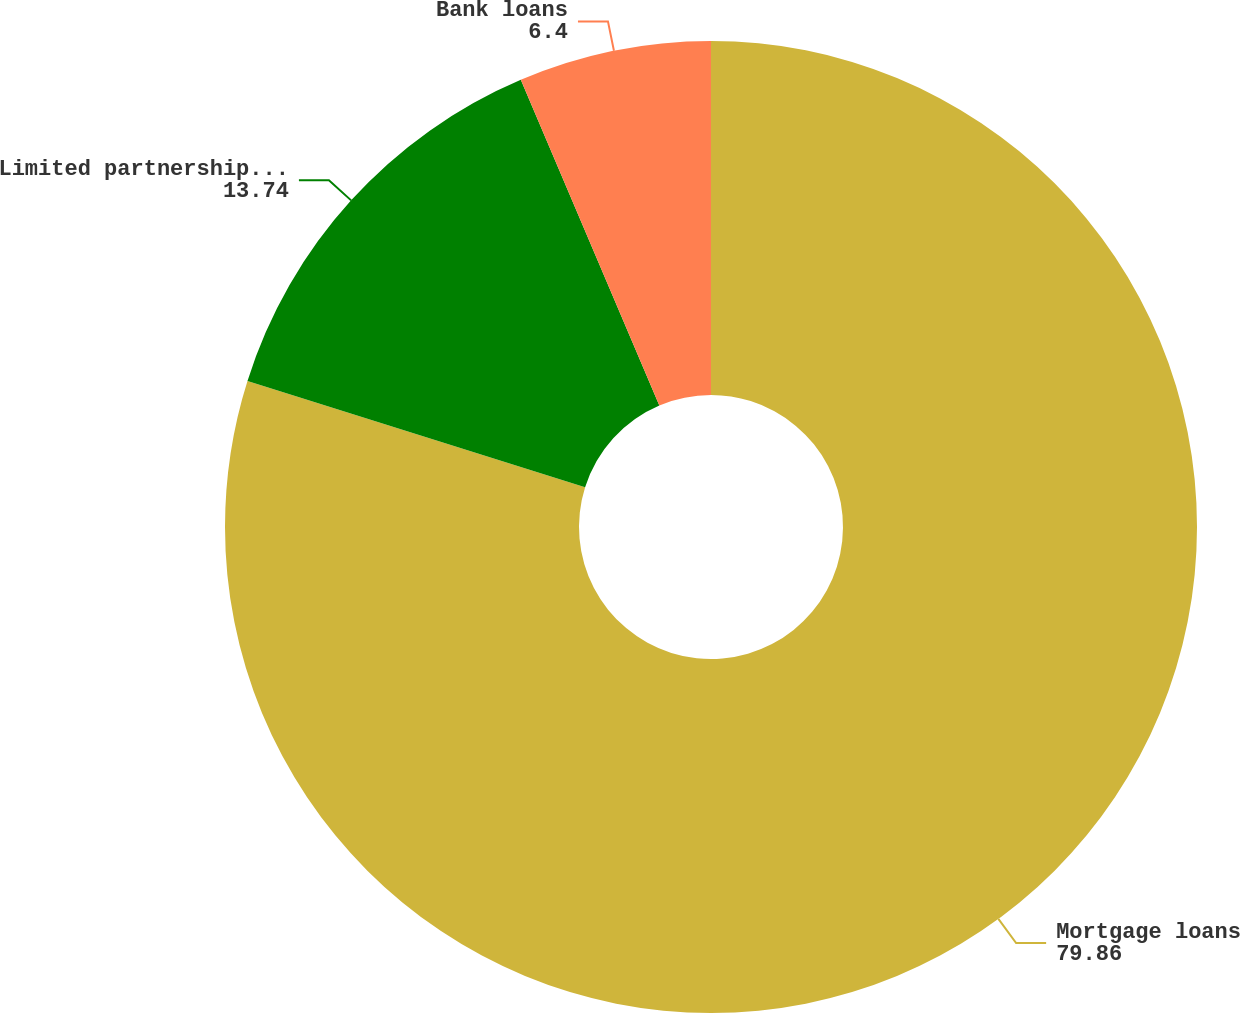Convert chart to OTSL. <chart><loc_0><loc_0><loc_500><loc_500><pie_chart><fcel>Mortgage loans<fcel>Limited partnership interests<fcel>Bank loans<nl><fcel>79.86%<fcel>13.74%<fcel>6.4%<nl></chart> 